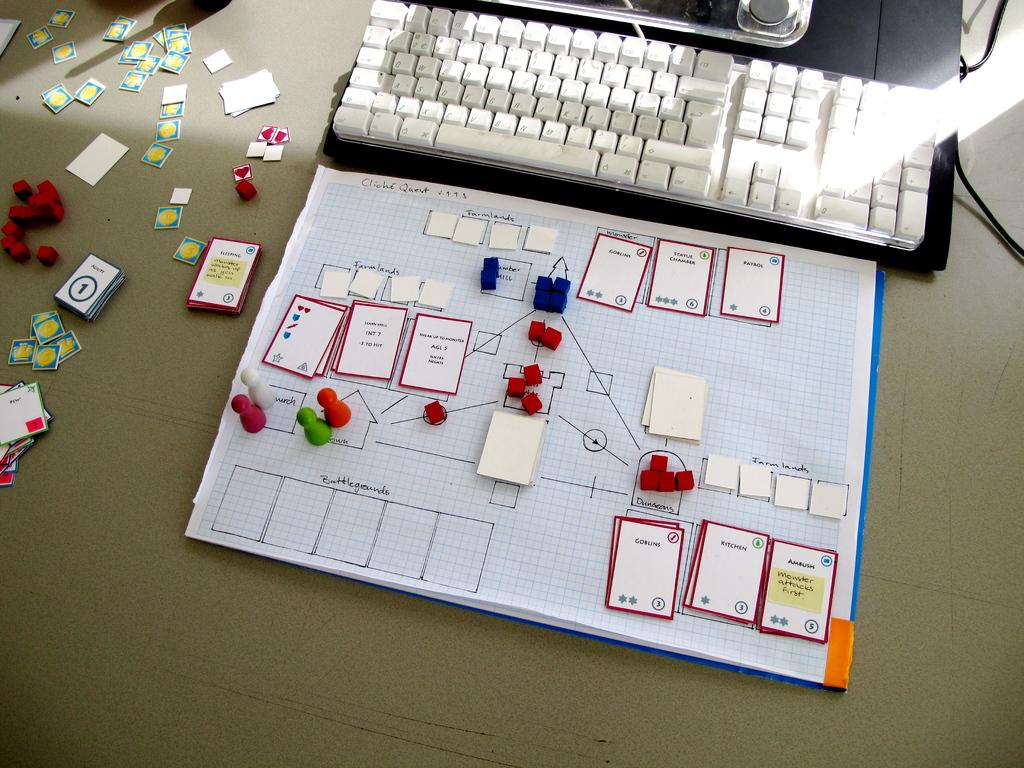<image>
Share a concise interpretation of the image provided. A chart that has several cards including one that says Kitchen. 